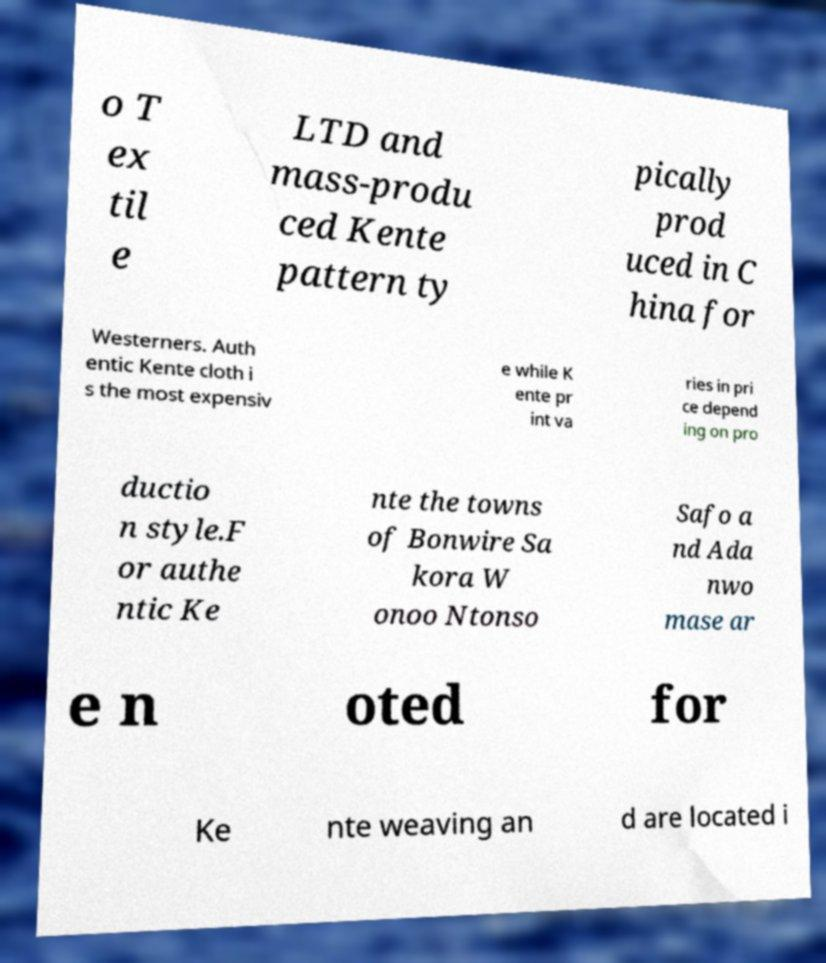Can you accurately transcribe the text from the provided image for me? o T ex til e LTD and mass-produ ced Kente pattern ty pically prod uced in C hina for Westerners. Auth entic Kente cloth i s the most expensiv e while K ente pr int va ries in pri ce depend ing on pro ductio n style.F or authe ntic Ke nte the towns of Bonwire Sa kora W onoo Ntonso Safo a nd Ada nwo mase ar e n oted for Ke nte weaving an d are located i 